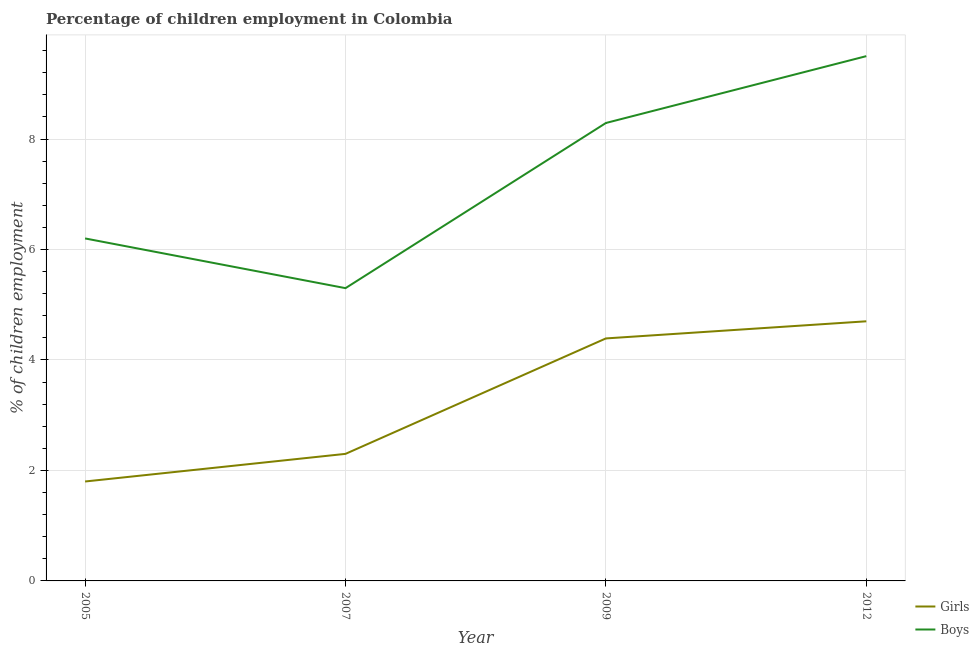How many different coloured lines are there?
Give a very brief answer. 2. Is the number of lines equal to the number of legend labels?
Provide a succinct answer. Yes. Across all years, what is the maximum percentage of employed boys?
Make the answer very short. 9.5. Across all years, what is the minimum percentage of employed girls?
Give a very brief answer. 1.8. In which year was the percentage of employed girls maximum?
Your answer should be compact. 2012. What is the total percentage of employed girls in the graph?
Keep it short and to the point. 13.19. What is the difference between the percentage of employed boys in 2009 and the percentage of employed girls in 2012?
Provide a succinct answer. 3.59. What is the average percentage of employed girls per year?
Ensure brevity in your answer.  3.3. In the year 2009, what is the difference between the percentage of employed boys and percentage of employed girls?
Your response must be concise. 3.9. In how many years, is the percentage of employed girls greater than 4.8 %?
Give a very brief answer. 0. What is the ratio of the percentage of employed boys in 2007 to that in 2012?
Your answer should be compact. 0.56. Is the difference between the percentage of employed girls in 2005 and 2012 greater than the difference between the percentage of employed boys in 2005 and 2012?
Your answer should be very brief. Yes. What is the difference between the highest and the second highest percentage of employed boys?
Offer a terse response. 1.21. What is the difference between the highest and the lowest percentage of employed boys?
Provide a succinct answer. 4.2. Is the sum of the percentage of employed girls in 2009 and 2012 greater than the maximum percentage of employed boys across all years?
Keep it short and to the point. No. Does the percentage of employed boys monotonically increase over the years?
Your answer should be very brief. No. Is the percentage of employed girls strictly greater than the percentage of employed boys over the years?
Your answer should be very brief. No. Is the percentage of employed boys strictly less than the percentage of employed girls over the years?
Ensure brevity in your answer.  No. How many years are there in the graph?
Keep it short and to the point. 4. Are the values on the major ticks of Y-axis written in scientific E-notation?
Your response must be concise. No. Does the graph contain any zero values?
Provide a succinct answer. No. Where does the legend appear in the graph?
Offer a very short reply. Bottom right. How many legend labels are there?
Provide a short and direct response. 2. What is the title of the graph?
Give a very brief answer. Percentage of children employment in Colombia. Does "Infant" appear as one of the legend labels in the graph?
Offer a very short reply. No. What is the label or title of the X-axis?
Keep it short and to the point. Year. What is the label or title of the Y-axis?
Provide a succinct answer. % of children employment. What is the % of children employment of Girls in 2005?
Offer a terse response. 1.8. What is the % of children employment in Boys in 2005?
Ensure brevity in your answer.  6.2. What is the % of children employment in Girls in 2007?
Make the answer very short. 2.3. What is the % of children employment of Boys in 2007?
Offer a very short reply. 5.3. What is the % of children employment in Girls in 2009?
Your response must be concise. 4.39. What is the % of children employment in Boys in 2009?
Offer a terse response. 8.29. What is the % of children employment in Girls in 2012?
Your response must be concise. 4.7. Across all years, what is the minimum % of children employment of Girls?
Make the answer very short. 1.8. What is the total % of children employment in Girls in the graph?
Your response must be concise. 13.19. What is the total % of children employment in Boys in the graph?
Your answer should be very brief. 29.29. What is the difference between the % of children employment in Girls in 2005 and that in 2007?
Your answer should be very brief. -0.5. What is the difference between the % of children employment in Girls in 2005 and that in 2009?
Your answer should be compact. -2.59. What is the difference between the % of children employment in Boys in 2005 and that in 2009?
Your response must be concise. -2.09. What is the difference between the % of children employment in Girls in 2005 and that in 2012?
Provide a short and direct response. -2.9. What is the difference between the % of children employment of Boys in 2005 and that in 2012?
Offer a very short reply. -3.3. What is the difference between the % of children employment in Girls in 2007 and that in 2009?
Provide a succinct answer. -2.09. What is the difference between the % of children employment in Boys in 2007 and that in 2009?
Your answer should be compact. -2.99. What is the difference between the % of children employment in Girls in 2007 and that in 2012?
Offer a terse response. -2.4. What is the difference between the % of children employment in Boys in 2007 and that in 2012?
Give a very brief answer. -4.2. What is the difference between the % of children employment in Girls in 2009 and that in 2012?
Offer a very short reply. -0.31. What is the difference between the % of children employment in Boys in 2009 and that in 2012?
Your response must be concise. -1.21. What is the difference between the % of children employment of Girls in 2005 and the % of children employment of Boys in 2007?
Provide a short and direct response. -3.5. What is the difference between the % of children employment in Girls in 2005 and the % of children employment in Boys in 2009?
Provide a short and direct response. -6.49. What is the difference between the % of children employment of Girls in 2005 and the % of children employment of Boys in 2012?
Give a very brief answer. -7.7. What is the difference between the % of children employment in Girls in 2007 and the % of children employment in Boys in 2009?
Make the answer very short. -5.99. What is the difference between the % of children employment in Girls in 2007 and the % of children employment in Boys in 2012?
Provide a succinct answer. -7.2. What is the difference between the % of children employment in Girls in 2009 and the % of children employment in Boys in 2012?
Provide a succinct answer. -5.11. What is the average % of children employment of Girls per year?
Offer a very short reply. 3.3. What is the average % of children employment of Boys per year?
Your response must be concise. 7.32. In the year 2005, what is the difference between the % of children employment in Girls and % of children employment in Boys?
Offer a terse response. -4.4. What is the ratio of the % of children employment of Girls in 2005 to that in 2007?
Your response must be concise. 0.78. What is the ratio of the % of children employment in Boys in 2005 to that in 2007?
Your answer should be very brief. 1.17. What is the ratio of the % of children employment in Girls in 2005 to that in 2009?
Keep it short and to the point. 0.41. What is the ratio of the % of children employment in Boys in 2005 to that in 2009?
Offer a very short reply. 0.75. What is the ratio of the % of children employment of Girls in 2005 to that in 2012?
Keep it short and to the point. 0.38. What is the ratio of the % of children employment in Boys in 2005 to that in 2012?
Keep it short and to the point. 0.65. What is the ratio of the % of children employment of Girls in 2007 to that in 2009?
Your answer should be compact. 0.52. What is the ratio of the % of children employment in Boys in 2007 to that in 2009?
Your answer should be very brief. 0.64. What is the ratio of the % of children employment of Girls in 2007 to that in 2012?
Your response must be concise. 0.49. What is the ratio of the % of children employment in Boys in 2007 to that in 2012?
Make the answer very short. 0.56. What is the ratio of the % of children employment in Girls in 2009 to that in 2012?
Provide a short and direct response. 0.93. What is the ratio of the % of children employment of Boys in 2009 to that in 2012?
Your answer should be compact. 0.87. What is the difference between the highest and the second highest % of children employment of Girls?
Your answer should be very brief. 0.31. What is the difference between the highest and the second highest % of children employment of Boys?
Provide a succinct answer. 1.21. What is the difference between the highest and the lowest % of children employment in Girls?
Give a very brief answer. 2.9. What is the difference between the highest and the lowest % of children employment in Boys?
Your response must be concise. 4.2. 